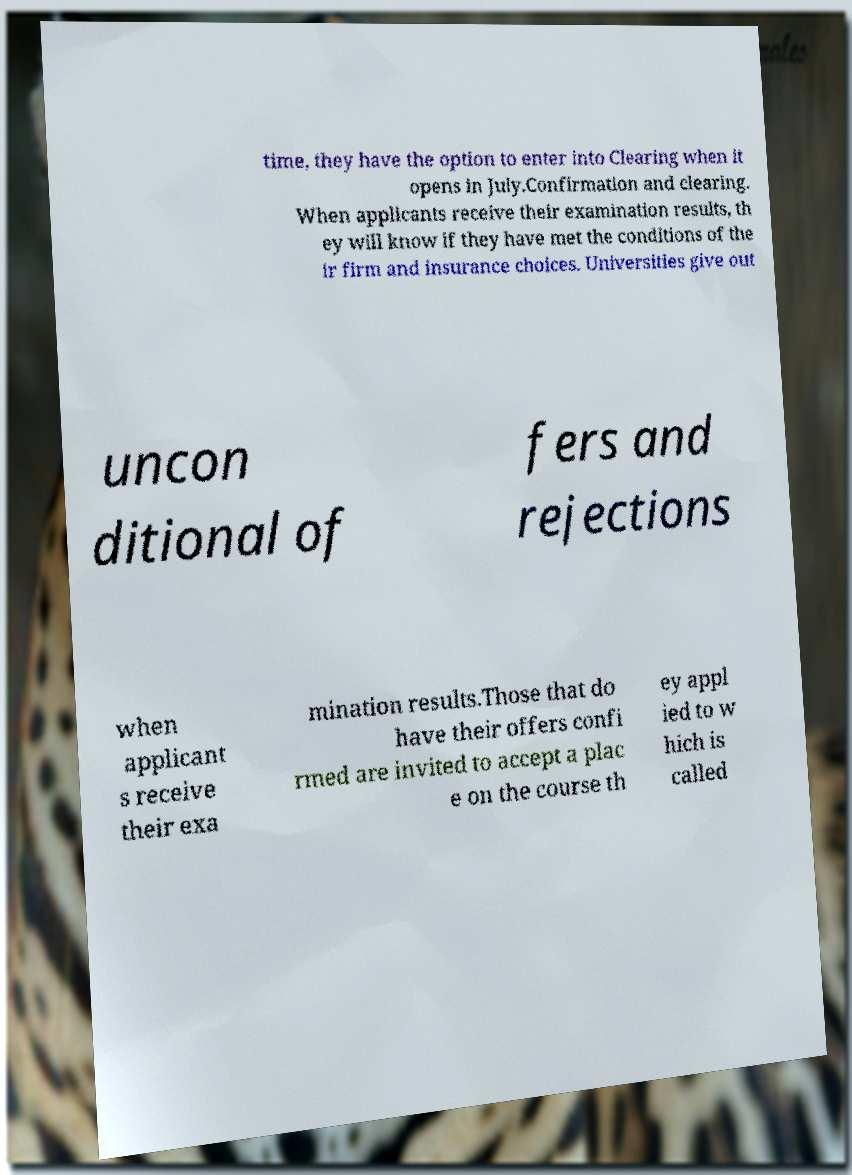What messages or text are displayed in this image? I need them in a readable, typed format. time, they have the option to enter into Clearing when it opens in July.Confirmation and clearing. When applicants receive their examination results, th ey will know if they have met the conditions of the ir firm and insurance choices. Universities give out uncon ditional of fers and rejections when applicant s receive their exa mination results.Those that do have their offers confi rmed are invited to accept a plac e on the course th ey appl ied to w hich is called 